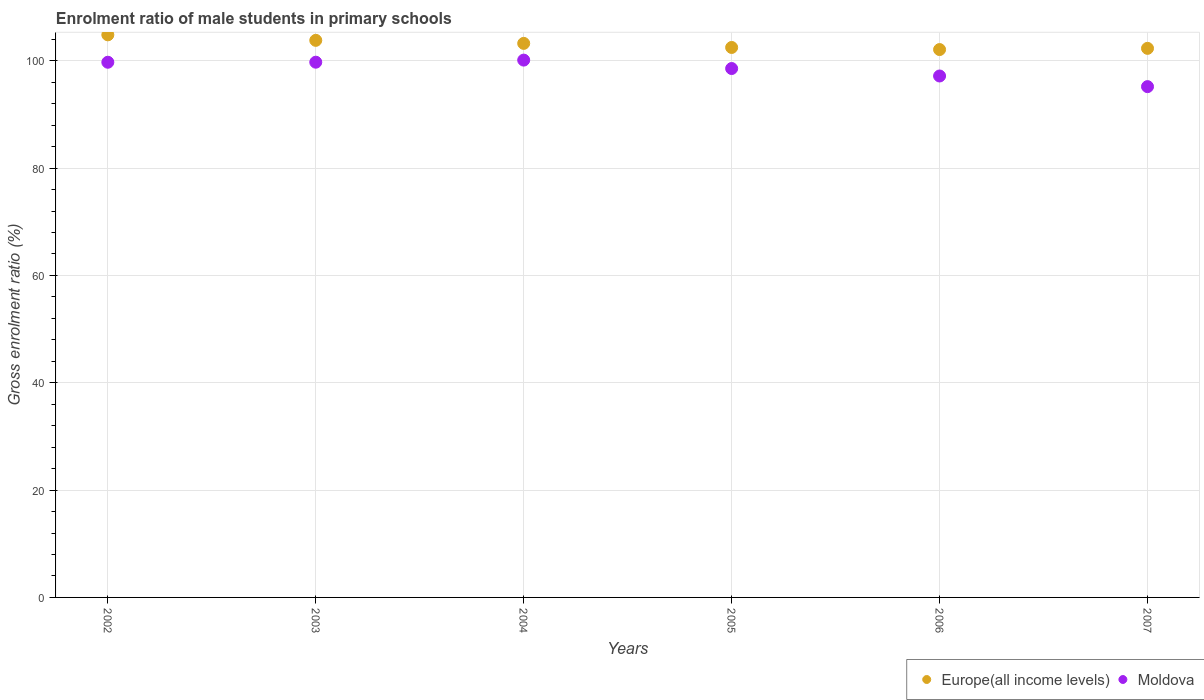Is the number of dotlines equal to the number of legend labels?
Your response must be concise. Yes. What is the enrolment ratio of male students in primary schools in Moldova in 2005?
Your answer should be compact. 98.55. Across all years, what is the maximum enrolment ratio of male students in primary schools in Moldova?
Provide a short and direct response. 100.12. Across all years, what is the minimum enrolment ratio of male students in primary schools in Moldova?
Your answer should be very brief. 95.18. In which year was the enrolment ratio of male students in primary schools in Europe(all income levels) maximum?
Your answer should be very brief. 2002. What is the total enrolment ratio of male students in primary schools in Europe(all income levels) in the graph?
Your answer should be very brief. 618.75. What is the difference between the enrolment ratio of male students in primary schools in Europe(all income levels) in 2002 and that in 2005?
Keep it short and to the point. 2.35. What is the difference between the enrolment ratio of male students in primary schools in Moldova in 2006 and the enrolment ratio of male students in primary schools in Europe(all income levels) in 2007?
Your response must be concise. -5.15. What is the average enrolment ratio of male students in primary schools in Europe(all income levels) per year?
Offer a very short reply. 103.12. In the year 2007, what is the difference between the enrolment ratio of male students in primary schools in Moldova and enrolment ratio of male students in primary schools in Europe(all income levels)?
Your answer should be very brief. -7.13. What is the ratio of the enrolment ratio of male students in primary schools in Europe(all income levels) in 2002 to that in 2005?
Keep it short and to the point. 1.02. Is the enrolment ratio of male students in primary schools in Moldova in 2002 less than that in 2007?
Your response must be concise. No. What is the difference between the highest and the second highest enrolment ratio of male students in primary schools in Europe(all income levels)?
Your answer should be compact. 1.03. What is the difference between the highest and the lowest enrolment ratio of male students in primary schools in Europe(all income levels)?
Offer a very short reply. 2.74. In how many years, is the enrolment ratio of male students in primary schools in Europe(all income levels) greater than the average enrolment ratio of male students in primary schools in Europe(all income levels) taken over all years?
Offer a terse response. 3. Is the sum of the enrolment ratio of male students in primary schools in Europe(all income levels) in 2003 and 2007 greater than the maximum enrolment ratio of male students in primary schools in Moldova across all years?
Offer a very short reply. Yes. Does the enrolment ratio of male students in primary schools in Moldova monotonically increase over the years?
Ensure brevity in your answer.  No. Is the enrolment ratio of male students in primary schools in Moldova strictly greater than the enrolment ratio of male students in primary schools in Europe(all income levels) over the years?
Your answer should be very brief. No. Is the enrolment ratio of male students in primary schools in Moldova strictly less than the enrolment ratio of male students in primary schools in Europe(all income levels) over the years?
Ensure brevity in your answer.  Yes. How many dotlines are there?
Your response must be concise. 2. What is the difference between two consecutive major ticks on the Y-axis?
Your answer should be compact. 20. Does the graph contain any zero values?
Keep it short and to the point. No. Does the graph contain grids?
Give a very brief answer. Yes. Where does the legend appear in the graph?
Your response must be concise. Bottom right. How many legend labels are there?
Provide a short and direct response. 2. What is the title of the graph?
Offer a very short reply. Enrolment ratio of male students in primary schools. What is the label or title of the Y-axis?
Provide a short and direct response. Gross enrolment ratio (%). What is the Gross enrolment ratio (%) in Europe(all income levels) in 2002?
Your answer should be very brief. 104.83. What is the Gross enrolment ratio (%) in Moldova in 2002?
Provide a short and direct response. 99.72. What is the Gross enrolment ratio (%) of Europe(all income levels) in 2003?
Provide a short and direct response. 103.8. What is the Gross enrolment ratio (%) in Moldova in 2003?
Give a very brief answer. 99.73. What is the Gross enrolment ratio (%) of Europe(all income levels) in 2004?
Give a very brief answer. 103.24. What is the Gross enrolment ratio (%) of Moldova in 2004?
Ensure brevity in your answer.  100.12. What is the Gross enrolment ratio (%) of Europe(all income levels) in 2005?
Ensure brevity in your answer.  102.48. What is the Gross enrolment ratio (%) of Moldova in 2005?
Your answer should be compact. 98.55. What is the Gross enrolment ratio (%) of Europe(all income levels) in 2006?
Provide a succinct answer. 102.09. What is the Gross enrolment ratio (%) of Moldova in 2006?
Offer a very short reply. 97.16. What is the Gross enrolment ratio (%) in Europe(all income levels) in 2007?
Keep it short and to the point. 102.31. What is the Gross enrolment ratio (%) in Moldova in 2007?
Keep it short and to the point. 95.18. Across all years, what is the maximum Gross enrolment ratio (%) of Europe(all income levels)?
Ensure brevity in your answer.  104.83. Across all years, what is the maximum Gross enrolment ratio (%) of Moldova?
Make the answer very short. 100.12. Across all years, what is the minimum Gross enrolment ratio (%) in Europe(all income levels)?
Offer a very short reply. 102.09. Across all years, what is the minimum Gross enrolment ratio (%) in Moldova?
Give a very brief answer. 95.18. What is the total Gross enrolment ratio (%) of Europe(all income levels) in the graph?
Offer a very short reply. 618.75. What is the total Gross enrolment ratio (%) of Moldova in the graph?
Offer a terse response. 590.47. What is the difference between the Gross enrolment ratio (%) in Europe(all income levels) in 2002 and that in 2003?
Make the answer very short. 1.03. What is the difference between the Gross enrolment ratio (%) in Moldova in 2002 and that in 2003?
Offer a terse response. -0.01. What is the difference between the Gross enrolment ratio (%) of Europe(all income levels) in 2002 and that in 2004?
Your answer should be compact. 1.59. What is the difference between the Gross enrolment ratio (%) of Moldova in 2002 and that in 2004?
Your answer should be compact. -0.4. What is the difference between the Gross enrolment ratio (%) of Europe(all income levels) in 2002 and that in 2005?
Give a very brief answer. 2.35. What is the difference between the Gross enrolment ratio (%) of Moldova in 2002 and that in 2005?
Provide a succinct answer. 1.17. What is the difference between the Gross enrolment ratio (%) in Europe(all income levels) in 2002 and that in 2006?
Provide a short and direct response. 2.74. What is the difference between the Gross enrolment ratio (%) of Moldova in 2002 and that in 2006?
Your response must be concise. 2.56. What is the difference between the Gross enrolment ratio (%) in Europe(all income levels) in 2002 and that in 2007?
Your answer should be very brief. 2.52. What is the difference between the Gross enrolment ratio (%) of Moldova in 2002 and that in 2007?
Make the answer very short. 4.54. What is the difference between the Gross enrolment ratio (%) of Europe(all income levels) in 2003 and that in 2004?
Give a very brief answer. 0.57. What is the difference between the Gross enrolment ratio (%) of Moldova in 2003 and that in 2004?
Your answer should be very brief. -0.39. What is the difference between the Gross enrolment ratio (%) of Europe(all income levels) in 2003 and that in 2005?
Offer a terse response. 1.33. What is the difference between the Gross enrolment ratio (%) of Moldova in 2003 and that in 2005?
Ensure brevity in your answer.  1.18. What is the difference between the Gross enrolment ratio (%) of Europe(all income levels) in 2003 and that in 2006?
Provide a succinct answer. 1.72. What is the difference between the Gross enrolment ratio (%) in Moldova in 2003 and that in 2006?
Keep it short and to the point. 2.57. What is the difference between the Gross enrolment ratio (%) of Europe(all income levels) in 2003 and that in 2007?
Ensure brevity in your answer.  1.49. What is the difference between the Gross enrolment ratio (%) in Moldova in 2003 and that in 2007?
Ensure brevity in your answer.  4.55. What is the difference between the Gross enrolment ratio (%) in Europe(all income levels) in 2004 and that in 2005?
Make the answer very short. 0.76. What is the difference between the Gross enrolment ratio (%) in Moldova in 2004 and that in 2005?
Give a very brief answer. 1.57. What is the difference between the Gross enrolment ratio (%) in Europe(all income levels) in 2004 and that in 2006?
Your answer should be compact. 1.15. What is the difference between the Gross enrolment ratio (%) in Moldova in 2004 and that in 2006?
Offer a very short reply. 2.96. What is the difference between the Gross enrolment ratio (%) of Europe(all income levels) in 2004 and that in 2007?
Your response must be concise. 0.93. What is the difference between the Gross enrolment ratio (%) of Moldova in 2004 and that in 2007?
Ensure brevity in your answer.  4.94. What is the difference between the Gross enrolment ratio (%) in Europe(all income levels) in 2005 and that in 2006?
Offer a very short reply. 0.39. What is the difference between the Gross enrolment ratio (%) of Moldova in 2005 and that in 2006?
Provide a succinct answer. 1.39. What is the difference between the Gross enrolment ratio (%) in Europe(all income levels) in 2005 and that in 2007?
Keep it short and to the point. 0.17. What is the difference between the Gross enrolment ratio (%) of Moldova in 2005 and that in 2007?
Your response must be concise. 3.37. What is the difference between the Gross enrolment ratio (%) in Europe(all income levels) in 2006 and that in 2007?
Your answer should be very brief. -0.22. What is the difference between the Gross enrolment ratio (%) in Moldova in 2006 and that in 2007?
Your answer should be very brief. 1.98. What is the difference between the Gross enrolment ratio (%) in Europe(all income levels) in 2002 and the Gross enrolment ratio (%) in Moldova in 2003?
Your answer should be compact. 5.1. What is the difference between the Gross enrolment ratio (%) of Europe(all income levels) in 2002 and the Gross enrolment ratio (%) of Moldova in 2004?
Your response must be concise. 4.71. What is the difference between the Gross enrolment ratio (%) in Europe(all income levels) in 2002 and the Gross enrolment ratio (%) in Moldova in 2005?
Provide a succinct answer. 6.28. What is the difference between the Gross enrolment ratio (%) in Europe(all income levels) in 2002 and the Gross enrolment ratio (%) in Moldova in 2006?
Make the answer very short. 7.67. What is the difference between the Gross enrolment ratio (%) of Europe(all income levels) in 2002 and the Gross enrolment ratio (%) of Moldova in 2007?
Offer a very short reply. 9.65. What is the difference between the Gross enrolment ratio (%) in Europe(all income levels) in 2003 and the Gross enrolment ratio (%) in Moldova in 2004?
Provide a short and direct response. 3.68. What is the difference between the Gross enrolment ratio (%) of Europe(all income levels) in 2003 and the Gross enrolment ratio (%) of Moldova in 2005?
Make the answer very short. 5.25. What is the difference between the Gross enrolment ratio (%) in Europe(all income levels) in 2003 and the Gross enrolment ratio (%) in Moldova in 2006?
Your response must be concise. 6.64. What is the difference between the Gross enrolment ratio (%) in Europe(all income levels) in 2003 and the Gross enrolment ratio (%) in Moldova in 2007?
Offer a terse response. 8.62. What is the difference between the Gross enrolment ratio (%) of Europe(all income levels) in 2004 and the Gross enrolment ratio (%) of Moldova in 2005?
Make the answer very short. 4.68. What is the difference between the Gross enrolment ratio (%) in Europe(all income levels) in 2004 and the Gross enrolment ratio (%) in Moldova in 2006?
Your answer should be very brief. 6.07. What is the difference between the Gross enrolment ratio (%) of Europe(all income levels) in 2004 and the Gross enrolment ratio (%) of Moldova in 2007?
Make the answer very short. 8.06. What is the difference between the Gross enrolment ratio (%) of Europe(all income levels) in 2005 and the Gross enrolment ratio (%) of Moldova in 2006?
Make the answer very short. 5.32. What is the difference between the Gross enrolment ratio (%) of Europe(all income levels) in 2005 and the Gross enrolment ratio (%) of Moldova in 2007?
Provide a short and direct response. 7.3. What is the difference between the Gross enrolment ratio (%) of Europe(all income levels) in 2006 and the Gross enrolment ratio (%) of Moldova in 2007?
Your answer should be compact. 6.91. What is the average Gross enrolment ratio (%) of Europe(all income levels) per year?
Your response must be concise. 103.12. What is the average Gross enrolment ratio (%) of Moldova per year?
Make the answer very short. 98.41. In the year 2002, what is the difference between the Gross enrolment ratio (%) in Europe(all income levels) and Gross enrolment ratio (%) in Moldova?
Your answer should be compact. 5.11. In the year 2003, what is the difference between the Gross enrolment ratio (%) of Europe(all income levels) and Gross enrolment ratio (%) of Moldova?
Your answer should be very brief. 4.07. In the year 2004, what is the difference between the Gross enrolment ratio (%) in Europe(all income levels) and Gross enrolment ratio (%) in Moldova?
Your response must be concise. 3.12. In the year 2005, what is the difference between the Gross enrolment ratio (%) in Europe(all income levels) and Gross enrolment ratio (%) in Moldova?
Your response must be concise. 3.92. In the year 2006, what is the difference between the Gross enrolment ratio (%) in Europe(all income levels) and Gross enrolment ratio (%) in Moldova?
Provide a short and direct response. 4.93. In the year 2007, what is the difference between the Gross enrolment ratio (%) of Europe(all income levels) and Gross enrolment ratio (%) of Moldova?
Ensure brevity in your answer.  7.13. What is the ratio of the Gross enrolment ratio (%) in Europe(all income levels) in 2002 to that in 2003?
Offer a terse response. 1.01. What is the ratio of the Gross enrolment ratio (%) in Europe(all income levels) in 2002 to that in 2004?
Offer a very short reply. 1.02. What is the ratio of the Gross enrolment ratio (%) in Moldova in 2002 to that in 2004?
Provide a succinct answer. 1. What is the ratio of the Gross enrolment ratio (%) in Moldova in 2002 to that in 2005?
Make the answer very short. 1.01. What is the ratio of the Gross enrolment ratio (%) of Europe(all income levels) in 2002 to that in 2006?
Give a very brief answer. 1.03. What is the ratio of the Gross enrolment ratio (%) in Moldova in 2002 to that in 2006?
Your response must be concise. 1.03. What is the ratio of the Gross enrolment ratio (%) in Europe(all income levels) in 2002 to that in 2007?
Offer a very short reply. 1.02. What is the ratio of the Gross enrolment ratio (%) of Moldova in 2002 to that in 2007?
Provide a short and direct response. 1.05. What is the ratio of the Gross enrolment ratio (%) of Europe(all income levels) in 2003 to that in 2004?
Your response must be concise. 1.01. What is the ratio of the Gross enrolment ratio (%) in Europe(all income levels) in 2003 to that in 2005?
Offer a very short reply. 1.01. What is the ratio of the Gross enrolment ratio (%) of Europe(all income levels) in 2003 to that in 2006?
Keep it short and to the point. 1.02. What is the ratio of the Gross enrolment ratio (%) in Moldova in 2003 to that in 2006?
Your answer should be compact. 1.03. What is the ratio of the Gross enrolment ratio (%) in Europe(all income levels) in 2003 to that in 2007?
Your answer should be compact. 1.01. What is the ratio of the Gross enrolment ratio (%) in Moldova in 2003 to that in 2007?
Provide a short and direct response. 1.05. What is the ratio of the Gross enrolment ratio (%) in Europe(all income levels) in 2004 to that in 2005?
Your response must be concise. 1.01. What is the ratio of the Gross enrolment ratio (%) of Moldova in 2004 to that in 2005?
Offer a terse response. 1.02. What is the ratio of the Gross enrolment ratio (%) of Europe(all income levels) in 2004 to that in 2006?
Make the answer very short. 1.01. What is the ratio of the Gross enrolment ratio (%) in Moldova in 2004 to that in 2006?
Offer a terse response. 1.03. What is the ratio of the Gross enrolment ratio (%) in Moldova in 2004 to that in 2007?
Give a very brief answer. 1.05. What is the ratio of the Gross enrolment ratio (%) of Moldova in 2005 to that in 2006?
Your response must be concise. 1.01. What is the ratio of the Gross enrolment ratio (%) of Moldova in 2005 to that in 2007?
Ensure brevity in your answer.  1.04. What is the ratio of the Gross enrolment ratio (%) of Moldova in 2006 to that in 2007?
Give a very brief answer. 1.02. What is the difference between the highest and the second highest Gross enrolment ratio (%) of Europe(all income levels)?
Offer a very short reply. 1.03. What is the difference between the highest and the second highest Gross enrolment ratio (%) of Moldova?
Keep it short and to the point. 0.39. What is the difference between the highest and the lowest Gross enrolment ratio (%) of Europe(all income levels)?
Offer a very short reply. 2.74. What is the difference between the highest and the lowest Gross enrolment ratio (%) in Moldova?
Make the answer very short. 4.94. 